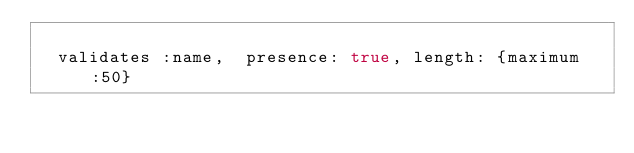Convert code to text. <code><loc_0><loc_0><loc_500><loc_500><_Ruby_>
  validates :name,  presence: true, length: {maximum:50}</code> 